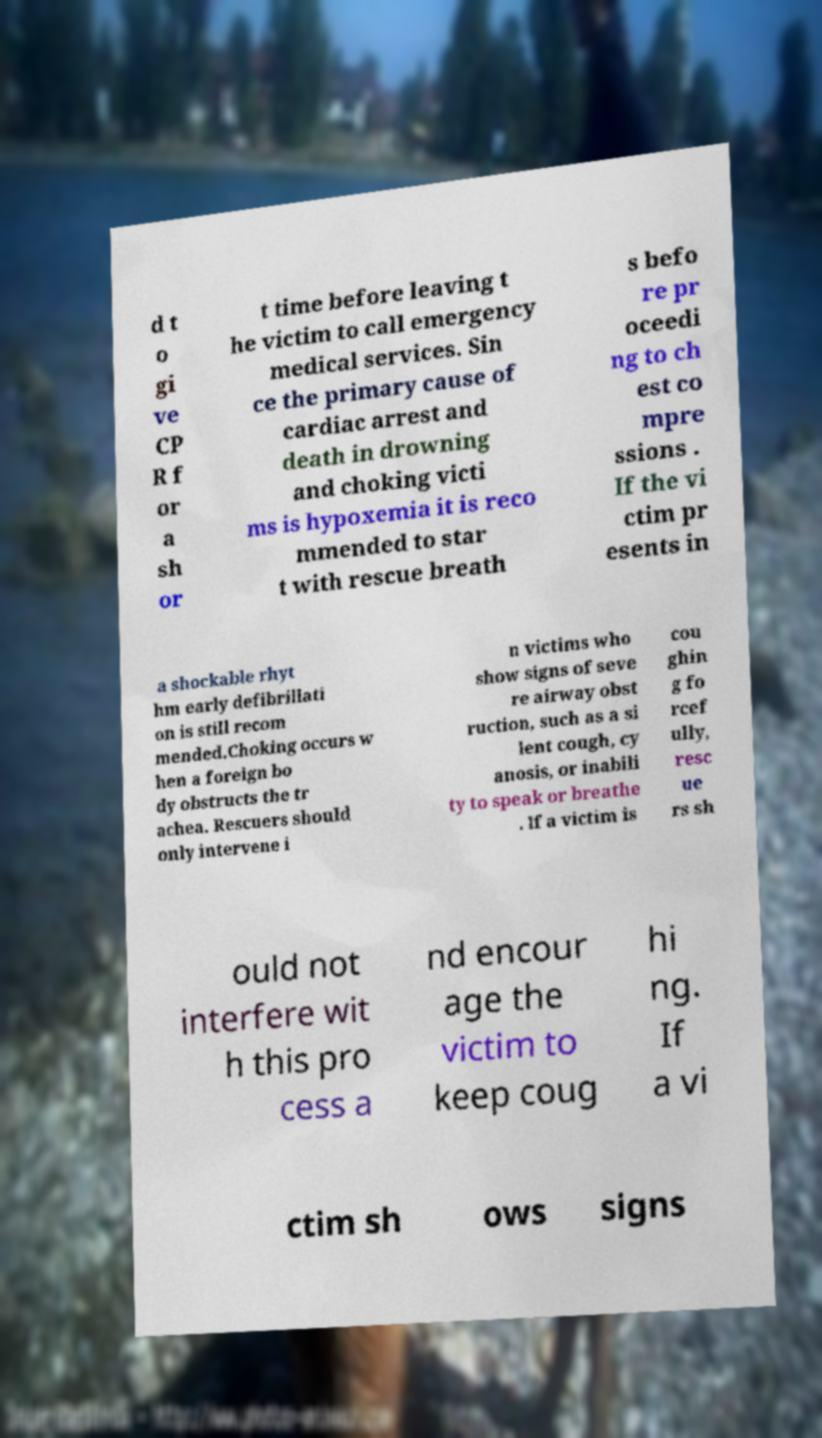Please read and relay the text visible in this image. What does it say? d t o gi ve CP R f or a sh or t time before leaving t he victim to call emergency medical services. Sin ce the primary cause of cardiac arrest and death in drowning and choking victi ms is hypoxemia it is reco mmended to star t with rescue breath s befo re pr oceedi ng to ch est co mpre ssions . If the vi ctim pr esents in a shockable rhyt hm early defibrillati on is still recom mended.Choking occurs w hen a foreign bo dy obstructs the tr achea. Rescuers should only intervene i n victims who show signs of seve re airway obst ruction, such as a si lent cough, cy anosis, or inabili ty to speak or breathe . If a victim is cou ghin g fo rcef ully, resc ue rs sh ould not interfere wit h this pro cess a nd encour age the victim to keep coug hi ng. If a vi ctim sh ows signs 